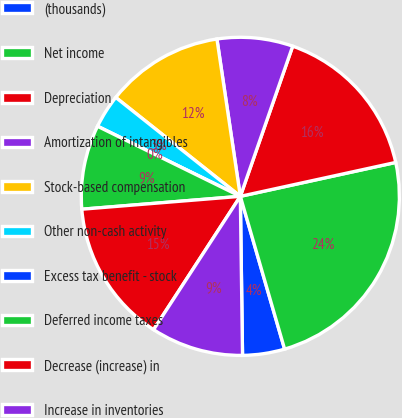Convert chart. <chart><loc_0><loc_0><loc_500><loc_500><pie_chart><fcel>(thousands)<fcel>Net income<fcel>Depreciation<fcel>Amortization of intangibles<fcel>Stock-based compensation<fcel>Other non-cash activity<fcel>Excess tax benefit - stock<fcel>Deferred income taxes<fcel>Decrease (increase) in<fcel>Increase in inventories<nl><fcel>4.27%<fcel>23.93%<fcel>16.24%<fcel>7.69%<fcel>11.97%<fcel>3.42%<fcel>0.0%<fcel>8.55%<fcel>14.53%<fcel>9.4%<nl></chart> 